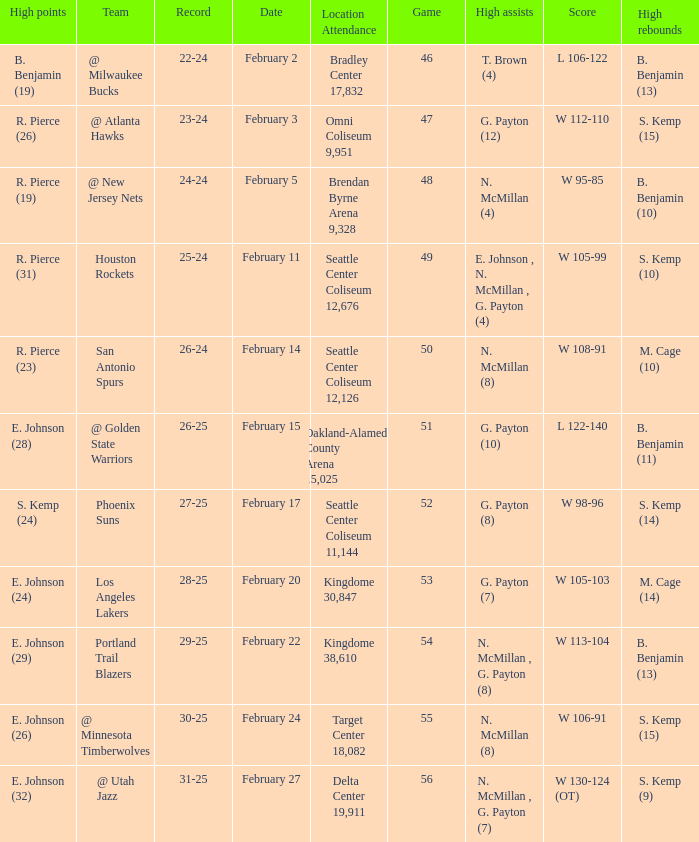What is the location and attendance for the game where b. benjamin (10) had the high rebounds? Brendan Byrne Arena 9,328. Parse the table in full. {'header': ['High points', 'Team', 'Record', 'Date', 'Location Attendance', 'Game', 'High assists', 'Score', 'High rebounds'], 'rows': [['B. Benjamin (19)', '@ Milwaukee Bucks', '22-24', 'February 2', 'Bradley Center 17,832', '46', 'T. Brown (4)', 'L 106-122', 'B. Benjamin (13)'], ['R. Pierce (26)', '@ Atlanta Hawks', '23-24', 'February 3', 'Omni Coliseum 9,951', '47', 'G. Payton (12)', 'W 112-110', 'S. Kemp (15)'], ['R. Pierce (19)', '@ New Jersey Nets', '24-24', 'February 5', 'Brendan Byrne Arena 9,328', '48', 'N. McMillan (4)', 'W 95-85', 'B. Benjamin (10)'], ['R. Pierce (31)', 'Houston Rockets', '25-24', 'February 11', 'Seattle Center Coliseum 12,676', '49', 'E. Johnson , N. McMillan , G. Payton (4)', 'W 105-99', 'S. Kemp (10)'], ['R. Pierce (23)', 'San Antonio Spurs', '26-24', 'February 14', 'Seattle Center Coliseum 12,126', '50', 'N. McMillan (8)', 'W 108-91', 'M. Cage (10)'], ['E. Johnson (28)', '@ Golden State Warriors', '26-25', 'February 15', 'Oakland-Alameda County Arena 15,025', '51', 'G. Payton (10)', 'L 122-140', 'B. Benjamin (11)'], ['S. Kemp (24)', 'Phoenix Suns', '27-25', 'February 17', 'Seattle Center Coliseum 11,144', '52', 'G. Payton (8)', 'W 98-96', 'S. Kemp (14)'], ['E. Johnson (24)', 'Los Angeles Lakers', '28-25', 'February 20', 'Kingdome 30,847', '53', 'G. Payton (7)', 'W 105-103', 'M. Cage (14)'], ['E. Johnson (29)', 'Portland Trail Blazers', '29-25', 'February 22', 'Kingdome 38,610', '54', 'N. McMillan , G. Payton (8)', 'W 113-104', 'B. Benjamin (13)'], ['E. Johnson (26)', '@ Minnesota Timberwolves', '30-25', 'February 24', 'Target Center 18,082', '55', 'N. McMillan (8)', 'W 106-91', 'S. Kemp (15)'], ['E. Johnson (32)', '@ Utah Jazz', '31-25', 'February 27', 'Delta Center 19,911', '56', 'N. McMillan , G. Payton (7)', 'W 130-124 (OT)', 'S. Kemp (9)']]} 